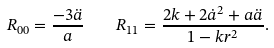<formula> <loc_0><loc_0><loc_500><loc_500>R _ { 0 0 } = \frac { - 3 \ddot { a } } { a } \quad R _ { 1 1 } = \frac { 2 k + 2 \dot { a } ^ { 2 } + a \ddot { a } } { 1 - k r ^ { 2 } } .</formula> 